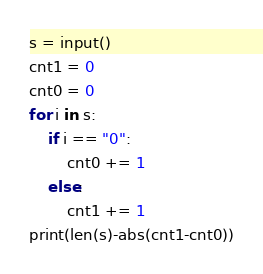<code> <loc_0><loc_0><loc_500><loc_500><_Python_>s = input()
cnt1 = 0
cnt0 = 0
for i in s:
    if i == "0":
        cnt0 += 1
    else:
        cnt1 += 1
print(len(s)-abs(cnt1-cnt0))</code> 